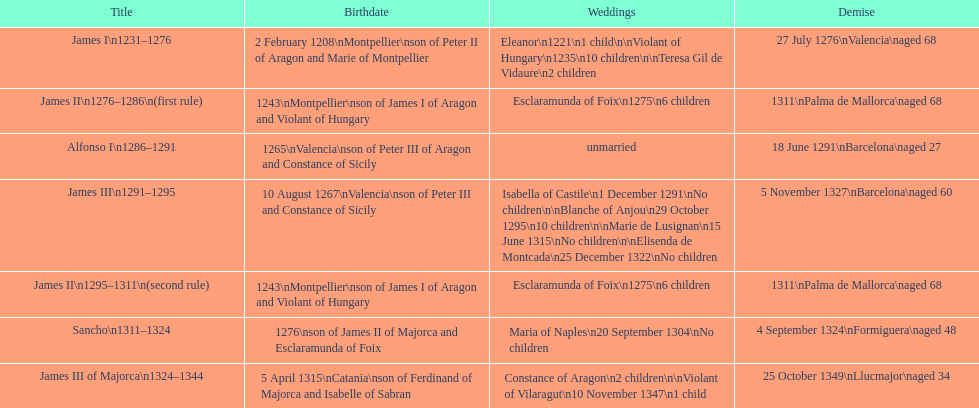James i and james ii both died at what age? 68. 